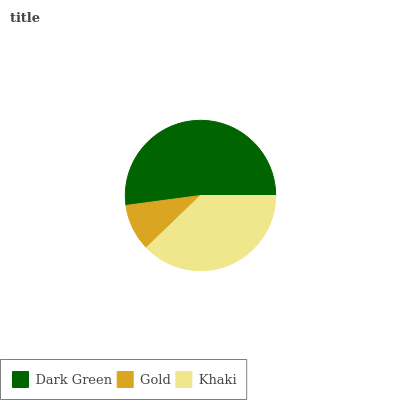Is Gold the minimum?
Answer yes or no. Yes. Is Dark Green the maximum?
Answer yes or no. Yes. Is Khaki the minimum?
Answer yes or no. No. Is Khaki the maximum?
Answer yes or no. No. Is Khaki greater than Gold?
Answer yes or no. Yes. Is Gold less than Khaki?
Answer yes or no. Yes. Is Gold greater than Khaki?
Answer yes or no. No. Is Khaki less than Gold?
Answer yes or no. No. Is Khaki the high median?
Answer yes or no. Yes. Is Khaki the low median?
Answer yes or no. Yes. Is Dark Green the high median?
Answer yes or no. No. Is Gold the low median?
Answer yes or no. No. 